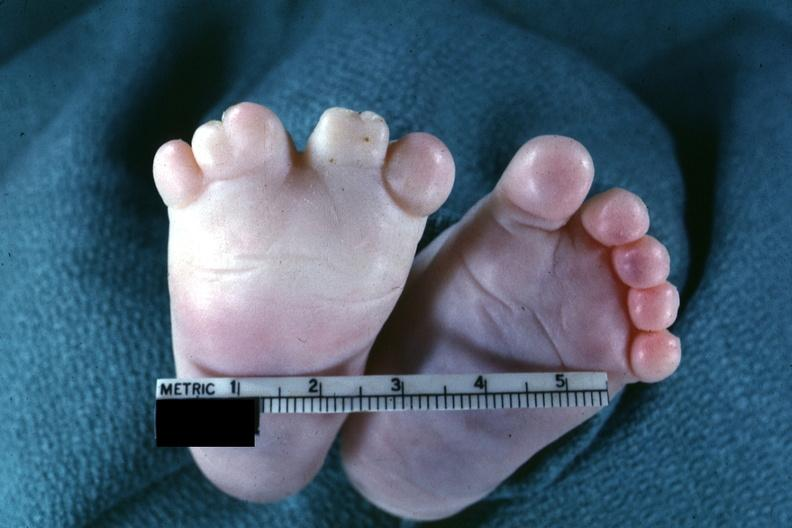what does this image show?
Answer the question using a single word or phrase. Very good example of syndactyly 